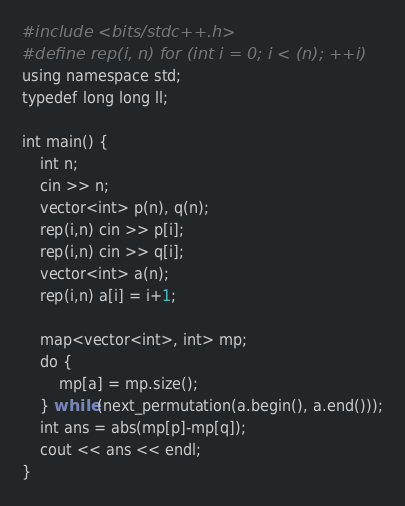Convert code to text. <code><loc_0><loc_0><loc_500><loc_500><_Python_>#include <bits/stdc++.h>
#define rep(i, n) for (int i = 0; i < (n); ++i)
using namespace std;
typedef long long ll;

int main() {
    int n;
    cin >> n;
    vector<int> p(n), q(n);
    rep(i,n) cin >> p[i];
    rep(i,n) cin >> q[i];
    vector<int> a(n);
    rep(i,n) a[i] = i+1;

    map<vector<int>, int> mp;
    do {
        mp[a] = mp.size();
    } while (next_permutation(a.begin(), a.end()));
    int ans = abs(mp[p]-mp[q]);
    cout << ans << endl;
}</code> 